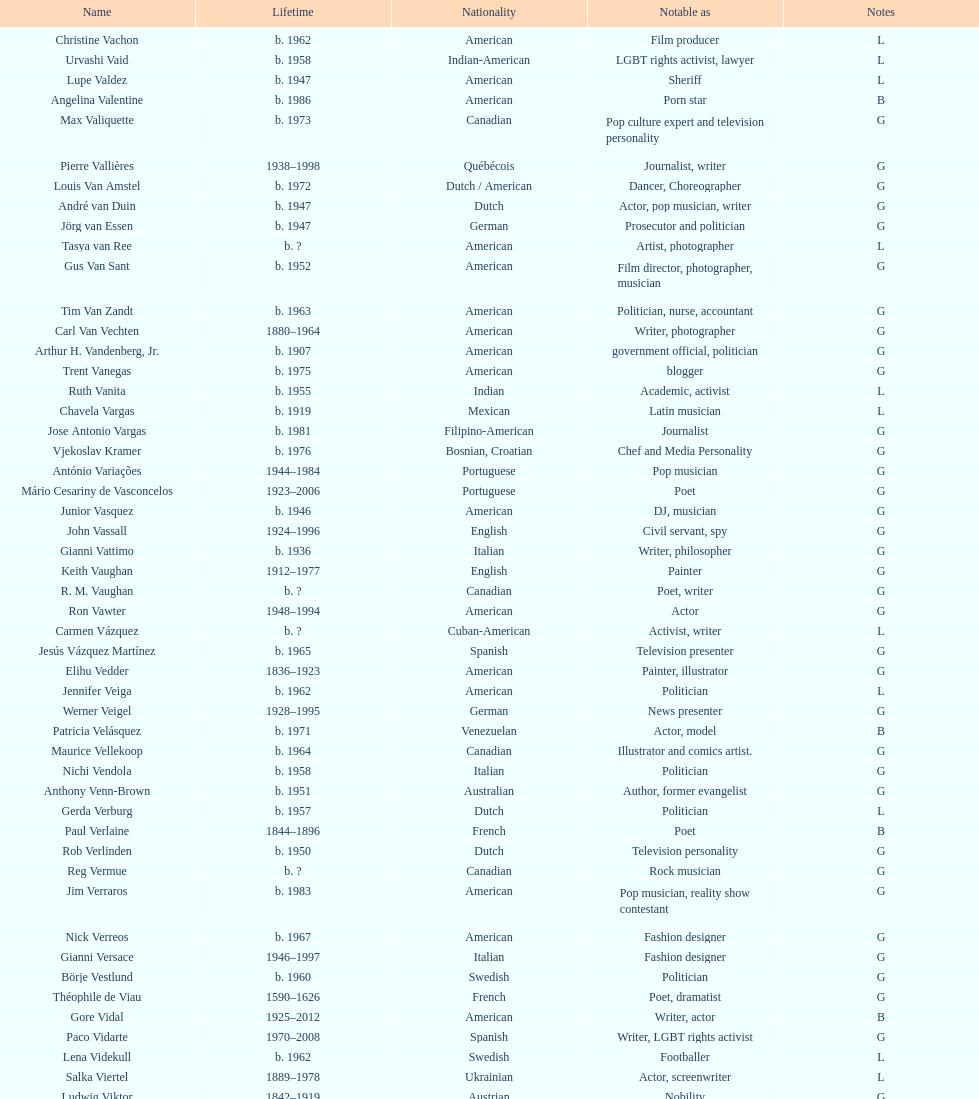Who was canadian, van amstel or valiquette? Valiquette. 